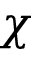<formula> <loc_0><loc_0><loc_500><loc_500>\chi</formula> 